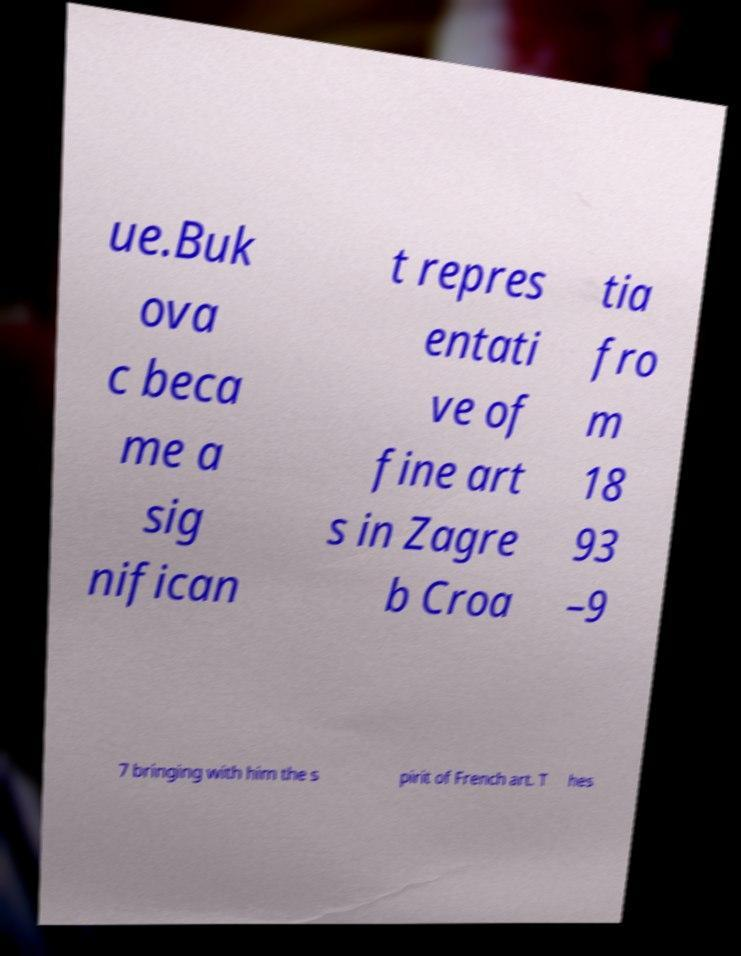Please read and relay the text visible in this image. What does it say? ue.Buk ova c beca me a sig nifican t repres entati ve of fine art s in Zagre b Croa tia fro m 18 93 –9 7 bringing with him the s pirit of French art. T hes 